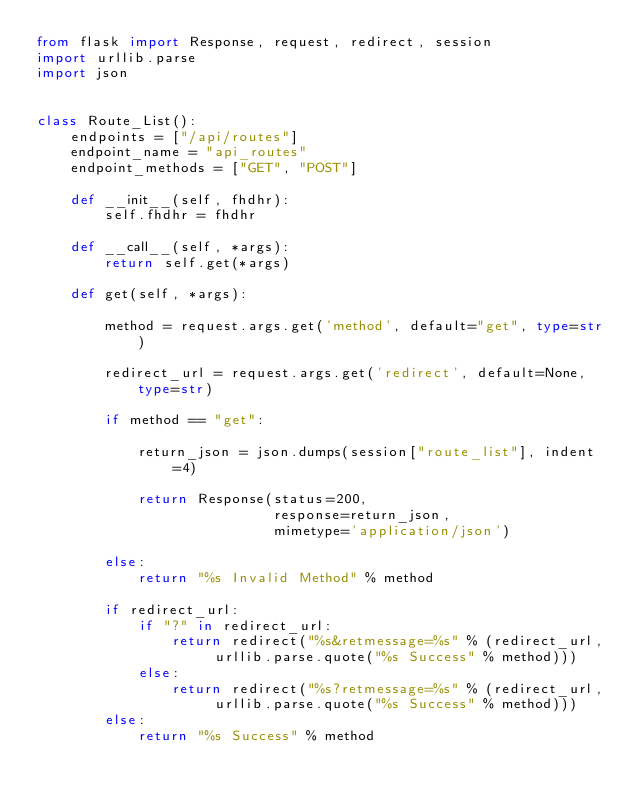Convert code to text. <code><loc_0><loc_0><loc_500><loc_500><_Python_>from flask import Response, request, redirect, session
import urllib.parse
import json


class Route_List():
    endpoints = ["/api/routes"]
    endpoint_name = "api_routes"
    endpoint_methods = ["GET", "POST"]

    def __init__(self, fhdhr):
        self.fhdhr = fhdhr

    def __call__(self, *args):
        return self.get(*args)

    def get(self, *args):

        method = request.args.get('method', default="get", type=str)

        redirect_url = request.args.get('redirect', default=None, type=str)

        if method == "get":

            return_json = json.dumps(session["route_list"], indent=4)

            return Response(status=200,
                            response=return_json,
                            mimetype='application/json')

        else:
            return "%s Invalid Method" % method

        if redirect_url:
            if "?" in redirect_url:
                return redirect("%s&retmessage=%s" % (redirect_url, urllib.parse.quote("%s Success" % method)))
            else:
                return redirect("%s?retmessage=%s" % (redirect_url, urllib.parse.quote("%s Success" % method)))
        else:
            return "%s Success" % method
</code> 